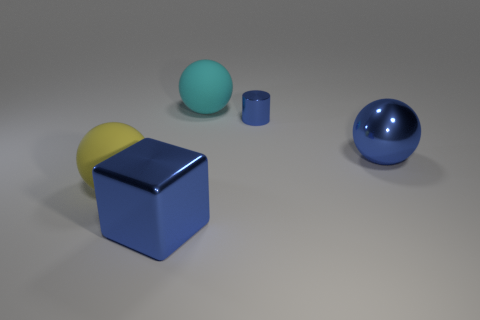Add 5 large yellow metal cylinders. How many objects exist? 10 Subtract all cylinders. How many objects are left? 4 Add 1 large blue metal blocks. How many large blue metal blocks exist? 2 Subtract 0 brown cubes. How many objects are left? 5 Subtract all big purple metallic cubes. Subtract all large cyan spheres. How many objects are left? 4 Add 3 blue cylinders. How many blue cylinders are left? 4 